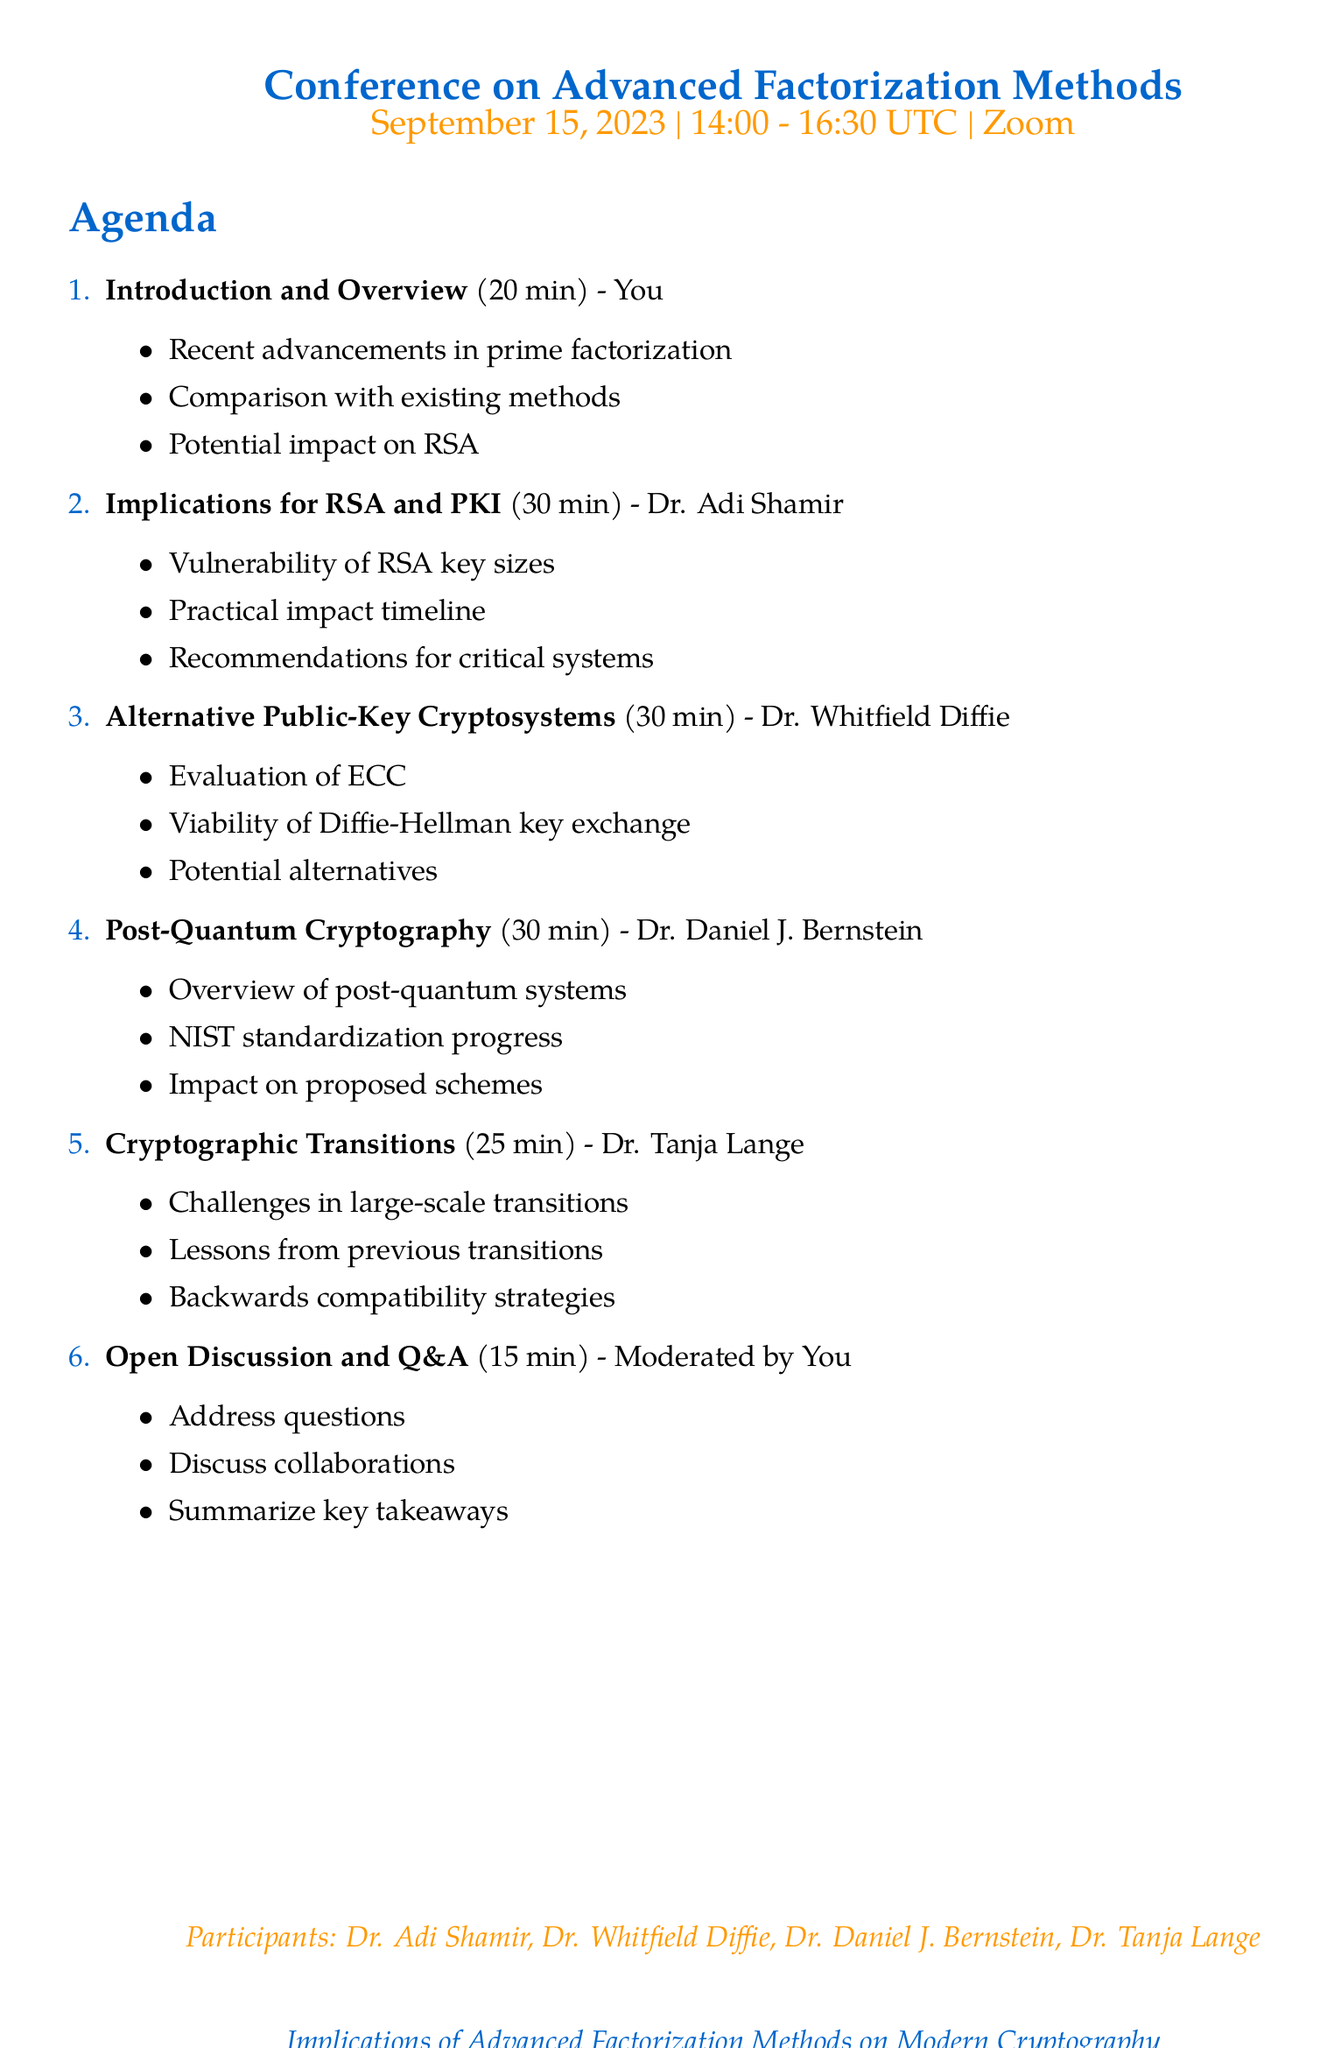What is the title of the conference? The title of the conference is listed at the top of the document.
Answer: Implications of Advanced Factorization Methods on Modern Cryptography Who is presenting the introduction and overview of recent advancements in prime factorization? This information can be found under the agenda item for the introduction and overview.
Answer: You How long is the session on post-quantum cryptography considerations? The duration of each session is provided next to each agenda item.
Answer: 30 minutes What date is the conference scheduled for? The date appears within the conference details section.
Answer: September 15, 2023 Which participant has expertise in elliptic curve cryptography? The expertise of each participant is listed next to their names.
Answer: Dr. Tanja Lange What is one of the key points discussed by Dr. Adi Shamir regarding RSA? The key points are detailed under the agenda item presented by Dr. Adi Shamir.
Answer: Vulnerability of different RSA key sizes What is the duration of the open discussion and Q&A session? The duration for each agenda item is specified in the document.
Answer: 15 minutes Which platform is being used for the conference? The platform information is mentioned in the conference details section.
Answer: Zoom 